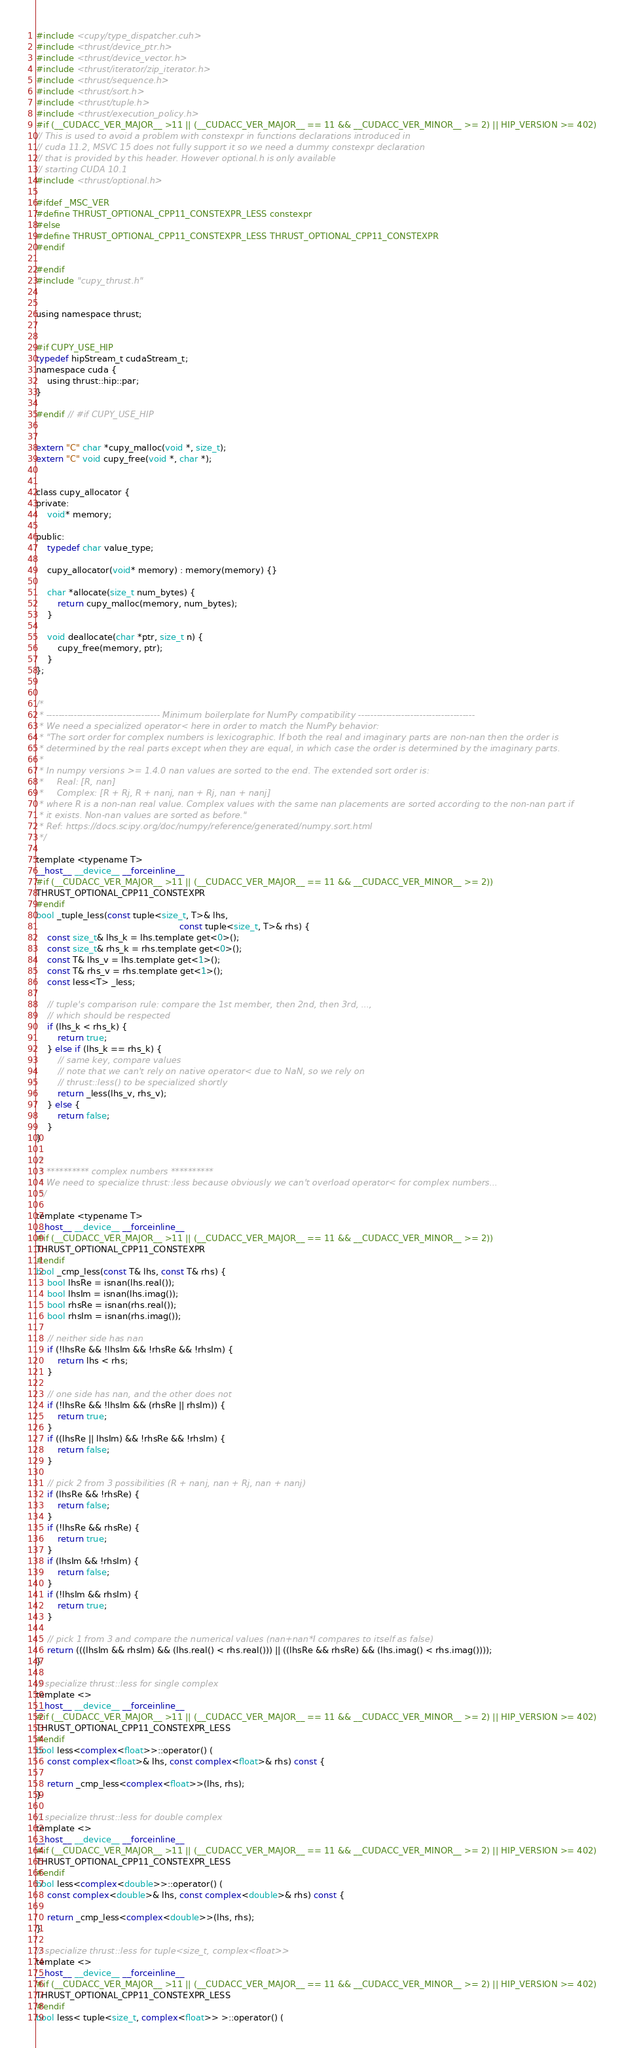<code> <loc_0><loc_0><loc_500><loc_500><_Cuda_>#include <cupy/type_dispatcher.cuh>
#include <thrust/device_ptr.h>
#include <thrust/device_vector.h>
#include <thrust/iterator/zip_iterator.h>
#include <thrust/sequence.h>
#include <thrust/sort.h>
#include <thrust/tuple.h>
#include <thrust/execution_policy.h>
#if (__CUDACC_VER_MAJOR__ >11 || (__CUDACC_VER_MAJOR__ == 11 && __CUDACC_VER_MINOR__ >= 2) || HIP_VERSION >= 402)
// This is used to avoid a problem with constexpr in functions declarations introduced in
// cuda 11.2, MSVC 15 does not fully support it so we need a dummy constexpr declaration
// that is provided by this header. However optional.h is only available
// starting CUDA 10.1
#include <thrust/optional.h>

#ifdef _MSC_VER
#define THRUST_OPTIONAL_CPP11_CONSTEXPR_LESS constexpr
#else
#define THRUST_OPTIONAL_CPP11_CONSTEXPR_LESS THRUST_OPTIONAL_CPP11_CONSTEXPR
#endif

#endif
#include "cupy_thrust.h"


using namespace thrust;


#if CUPY_USE_HIP
typedef hipStream_t cudaStream_t;
namespace cuda {
    using thrust::hip::par;
}

#endif // #if CUPY_USE_HIP


extern "C" char *cupy_malloc(void *, size_t);
extern "C" void cupy_free(void *, char *);


class cupy_allocator {
private:
    void* memory;

public:
    typedef char value_type;

    cupy_allocator(void* memory) : memory(memory) {}

    char *allocate(size_t num_bytes) {
        return cupy_malloc(memory, num_bytes);
    }

    void deallocate(char *ptr, size_t n) {
        cupy_free(memory, ptr);
    }
};


/*
 * ------------------------------------- Minimum boilerplate for NumPy compatibility --------------------------------------
 * We need a specialized operator< here in order to match the NumPy behavior:
 * "The sort order for complex numbers is lexicographic. If both the real and imaginary parts are non-nan then the order is
 * determined by the real parts except when they are equal, in which case the order is determined by the imaginary parts.
 *
 * In numpy versions >= 1.4.0 nan values are sorted to the end. The extended sort order is:
 *     Real: [R, nan]
 *     Complex: [R + Rj, R + nanj, nan + Rj, nan + nanj]
 * where R is a non-nan real value. Complex values with the same nan placements are sorted according to the non-nan part if
 * it exists. Non-nan values are sorted as before."
 * Ref: https://docs.scipy.org/doc/numpy/reference/generated/numpy.sort.html
 */

template <typename T>
__host__ __device__ __forceinline__ 
#if (__CUDACC_VER_MAJOR__ >11 || (__CUDACC_VER_MAJOR__ == 11 && __CUDACC_VER_MINOR__ >= 2))
THRUST_OPTIONAL_CPP11_CONSTEXPR
#endif
bool _tuple_less(const tuple<size_t, T>& lhs,
                                                     const tuple<size_t, T>& rhs) {
    const size_t& lhs_k = lhs.template get<0>();
    const size_t& rhs_k = rhs.template get<0>();
    const T& lhs_v = lhs.template get<1>();
    const T& rhs_v = rhs.template get<1>();
    const less<T> _less;

    // tuple's comparison rule: compare the 1st member, then 2nd, then 3rd, ...,
    // which should be respected
    if (lhs_k < rhs_k) {
        return true;
    } else if (lhs_k == rhs_k) {
        // same key, compare values
        // note that we can't rely on native operator< due to NaN, so we rely on
        // thrust::less() to be specialized shortly
        return _less(lhs_v, rhs_v);
    } else {
        return false;
    }
}

/*
 * ********** complex numbers **********
 * We need to specialize thrust::less because obviously we can't overload operator< for complex numbers...
 */

template <typename T>
__host__ __device__ __forceinline__
#if (__CUDACC_VER_MAJOR__ >11 || (__CUDACC_VER_MAJOR__ == 11 && __CUDACC_VER_MINOR__ >= 2))
THRUST_OPTIONAL_CPP11_CONSTEXPR
#endif
bool _cmp_less(const T& lhs, const T& rhs) {
    bool lhsRe = isnan(lhs.real());
    bool lhsIm = isnan(lhs.imag());
    bool rhsRe = isnan(rhs.real());
    bool rhsIm = isnan(rhs.imag());

    // neither side has nan
    if (!lhsRe && !lhsIm && !rhsRe && !rhsIm) {
        return lhs < rhs;
    }

    // one side has nan, and the other does not
    if (!lhsRe && !lhsIm && (rhsRe || rhsIm)) {
        return true;
    }
    if ((lhsRe || lhsIm) && !rhsRe && !rhsIm) {
        return false;
    }

    // pick 2 from 3 possibilities (R + nanj, nan + Rj, nan + nanj)
    if (lhsRe && !rhsRe) {
        return false;
    }
    if (!lhsRe && rhsRe) {
        return true;
    }
    if (lhsIm && !rhsIm) {
        return false;
    }
    if (!lhsIm && rhsIm) {
        return true;
    }

    // pick 1 from 3 and compare the numerical values (nan+nan*I compares to itself as false)
    return (((lhsIm && rhsIm) && (lhs.real() < rhs.real())) || ((lhsRe && rhsRe) && (lhs.imag() < rhs.imag())));
}

// specialize thrust::less for single complex
template <>
__host__ __device__ __forceinline__
#if (__CUDACC_VER_MAJOR__ >11 || (__CUDACC_VER_MAJOR__ == 11 && __CUDACC_VER_MINOR__ >= 2) || HIP_VERSION >= 402)
THRUST_OPTIONAL_CPP11_CONSTEXPR_LESS
#endif
bool less<complex<float>>::operator() (
    const complex<float>& lhs, const complex<float>& rhs) const {

    return _cmp_less<complex<float>>(lhs, rhs);
}

// specialize thrust::less for double complex
template <>
__host__ __device__ __forceinline__
#if (__CUDACC_VER_MAJOR__ >11 || (__CUDACC_VER_MAJOR__ == 11 && __CUDACC_VER_MINOR__ >= 2) || HIP_VERSION >= 402)
THRUST_OPTIONAL_CPP11_CONSTEXPR_LESS
#endif
bool less<complex<double>>::operator() (
    const complex<double>& lhs, const complex<double>& rhs) const {

    return _cmp_less<complex<double>>(lhs, rhs);
}

// specialize thrust::less for tuple<size_t, complex<float>>
template <>
__host__ __device__ __forceinline__
#if (__CUDACC_VER_MAJOR__ >11 || (__CUDACC_VER_MAJOR__ == 11 && __CUDACC_VER_MINOR__ >= 2) || HIP_VERSION >= 402)
THRUST_OPTIONAL_CPP11_CONSTEXPR_LESS
#endif
bool less< tuple<size_t, complex<float>> >::operator() (</code> 